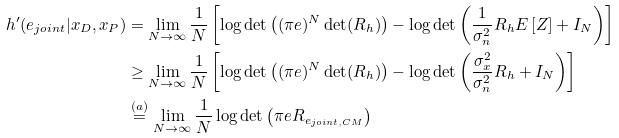Convert formula to latex. <formula><loc_0><loc_0><loc_500><loc_500>h ^ { \prime } ( e _ { j o i n t } | x _ { D } , x _ { P } ) & = \lim _ { N \rightarrow \infty } \frac { 1 } { N } \left [ \log \det \left ( ( \pi e ) ^ { N } \det ( R _ { h } ) \right ) - \log \det \left ( \frac { 1 } { \sigma _ { n } ^ { 2 } } R _ { h } E \left [ Z \right ] + I _ { N } \right ) \right ] \\ & \geq \lim _ { N \rightarrow \infty } \frac { 1 } { N } \left [ \log \det \left ( ( \pi e ) ^ { N } \det ( R _ { h } ) \right ) - \log \det \left ( \frac { \sigma _ { x } ^ { 2 } } { \sigma _ { n } ^ { 2 } } R _ { h } + I _ { N } \right ) \right ] \\ & \stackrel { ( a ) } { = } \lim _ { N \rightarrow \infty } \frac { 1 } { N } \log \det \left ( \pi e R _ { e _ { j o i n t , C M } } \right )</formula> 